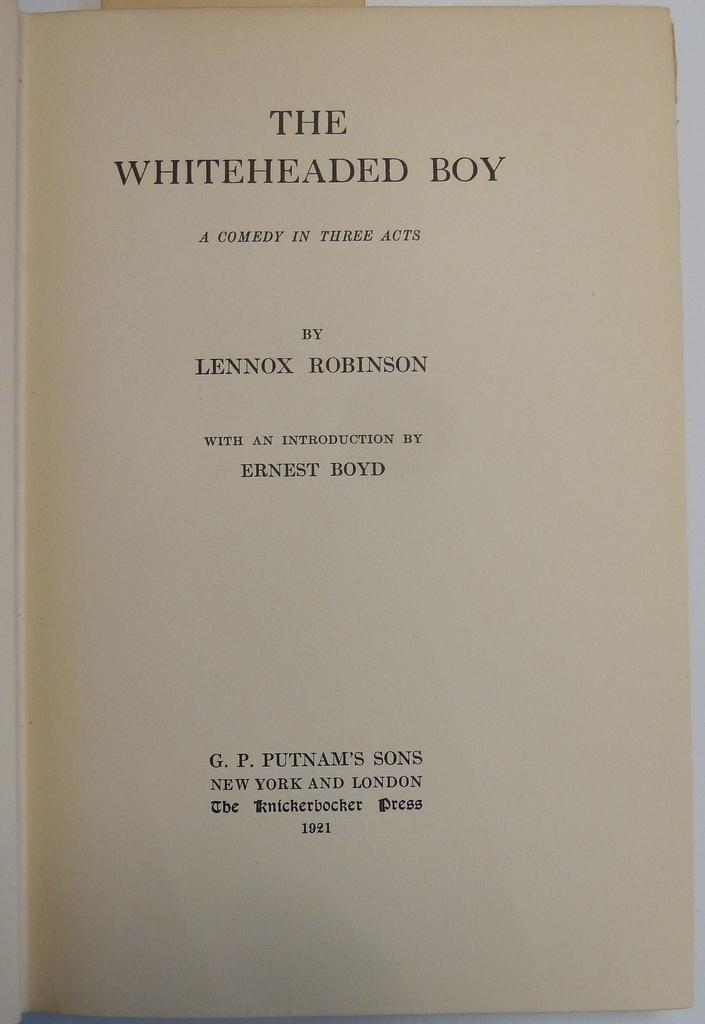<image>
Present a compact description of the photo's key features. A comedy play is titled The Whiteheaded Boy. 